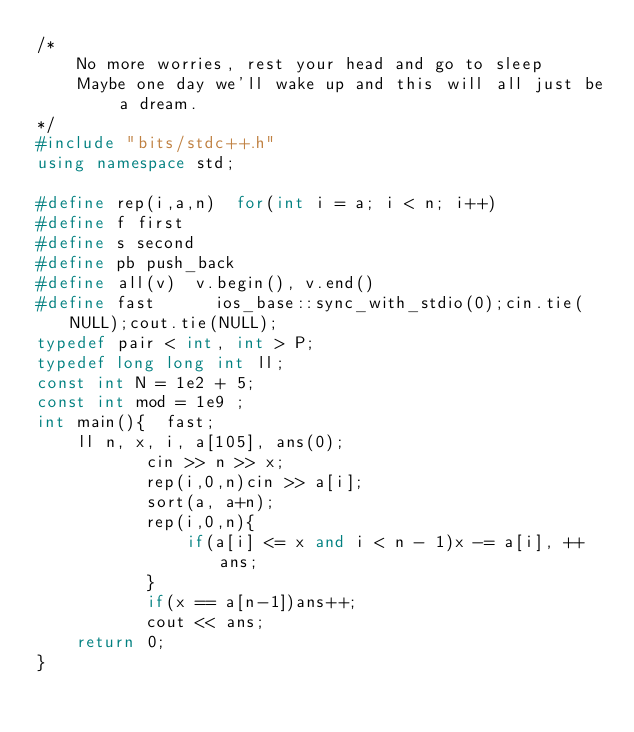<code> <loc_0><loc_0><loc_500><loc_500><_C++_>/* 
    No more worries, rest your head and go to sleep
    Maybe one day we'll wake up and this will all just be a dream.
*/
#include "bits/stdc++.h"
using namespace std;

#define rep(i,a,n)  for(int i = a; i < n; i++)
#define f first
#define s second
#define pb push_back
#define all(v)  v.begin(), v.end()
#define fast      ios_base::sync_with_stdio(0);cin.tie(NULL);cout.tie(NULL);
typedef pair < int, int > P;
typedef long long int ll;
const int N = 1e2 + 5;
const int mod = 1e9 ;
int main(){  fast;  
    ll n, x, i, a[105], ans(0);
           cin >> n >> x;
           rep(i,0,n)cin >> a[i];
           sort(a, a+n);
           rep(i,0,n){
               if(a[i] <= x and i < n - 1)x -= a[i], ++ans;
           }
           if(x == a[n-1])ans++;
           cout << ans;
    return 0;
}</code> 